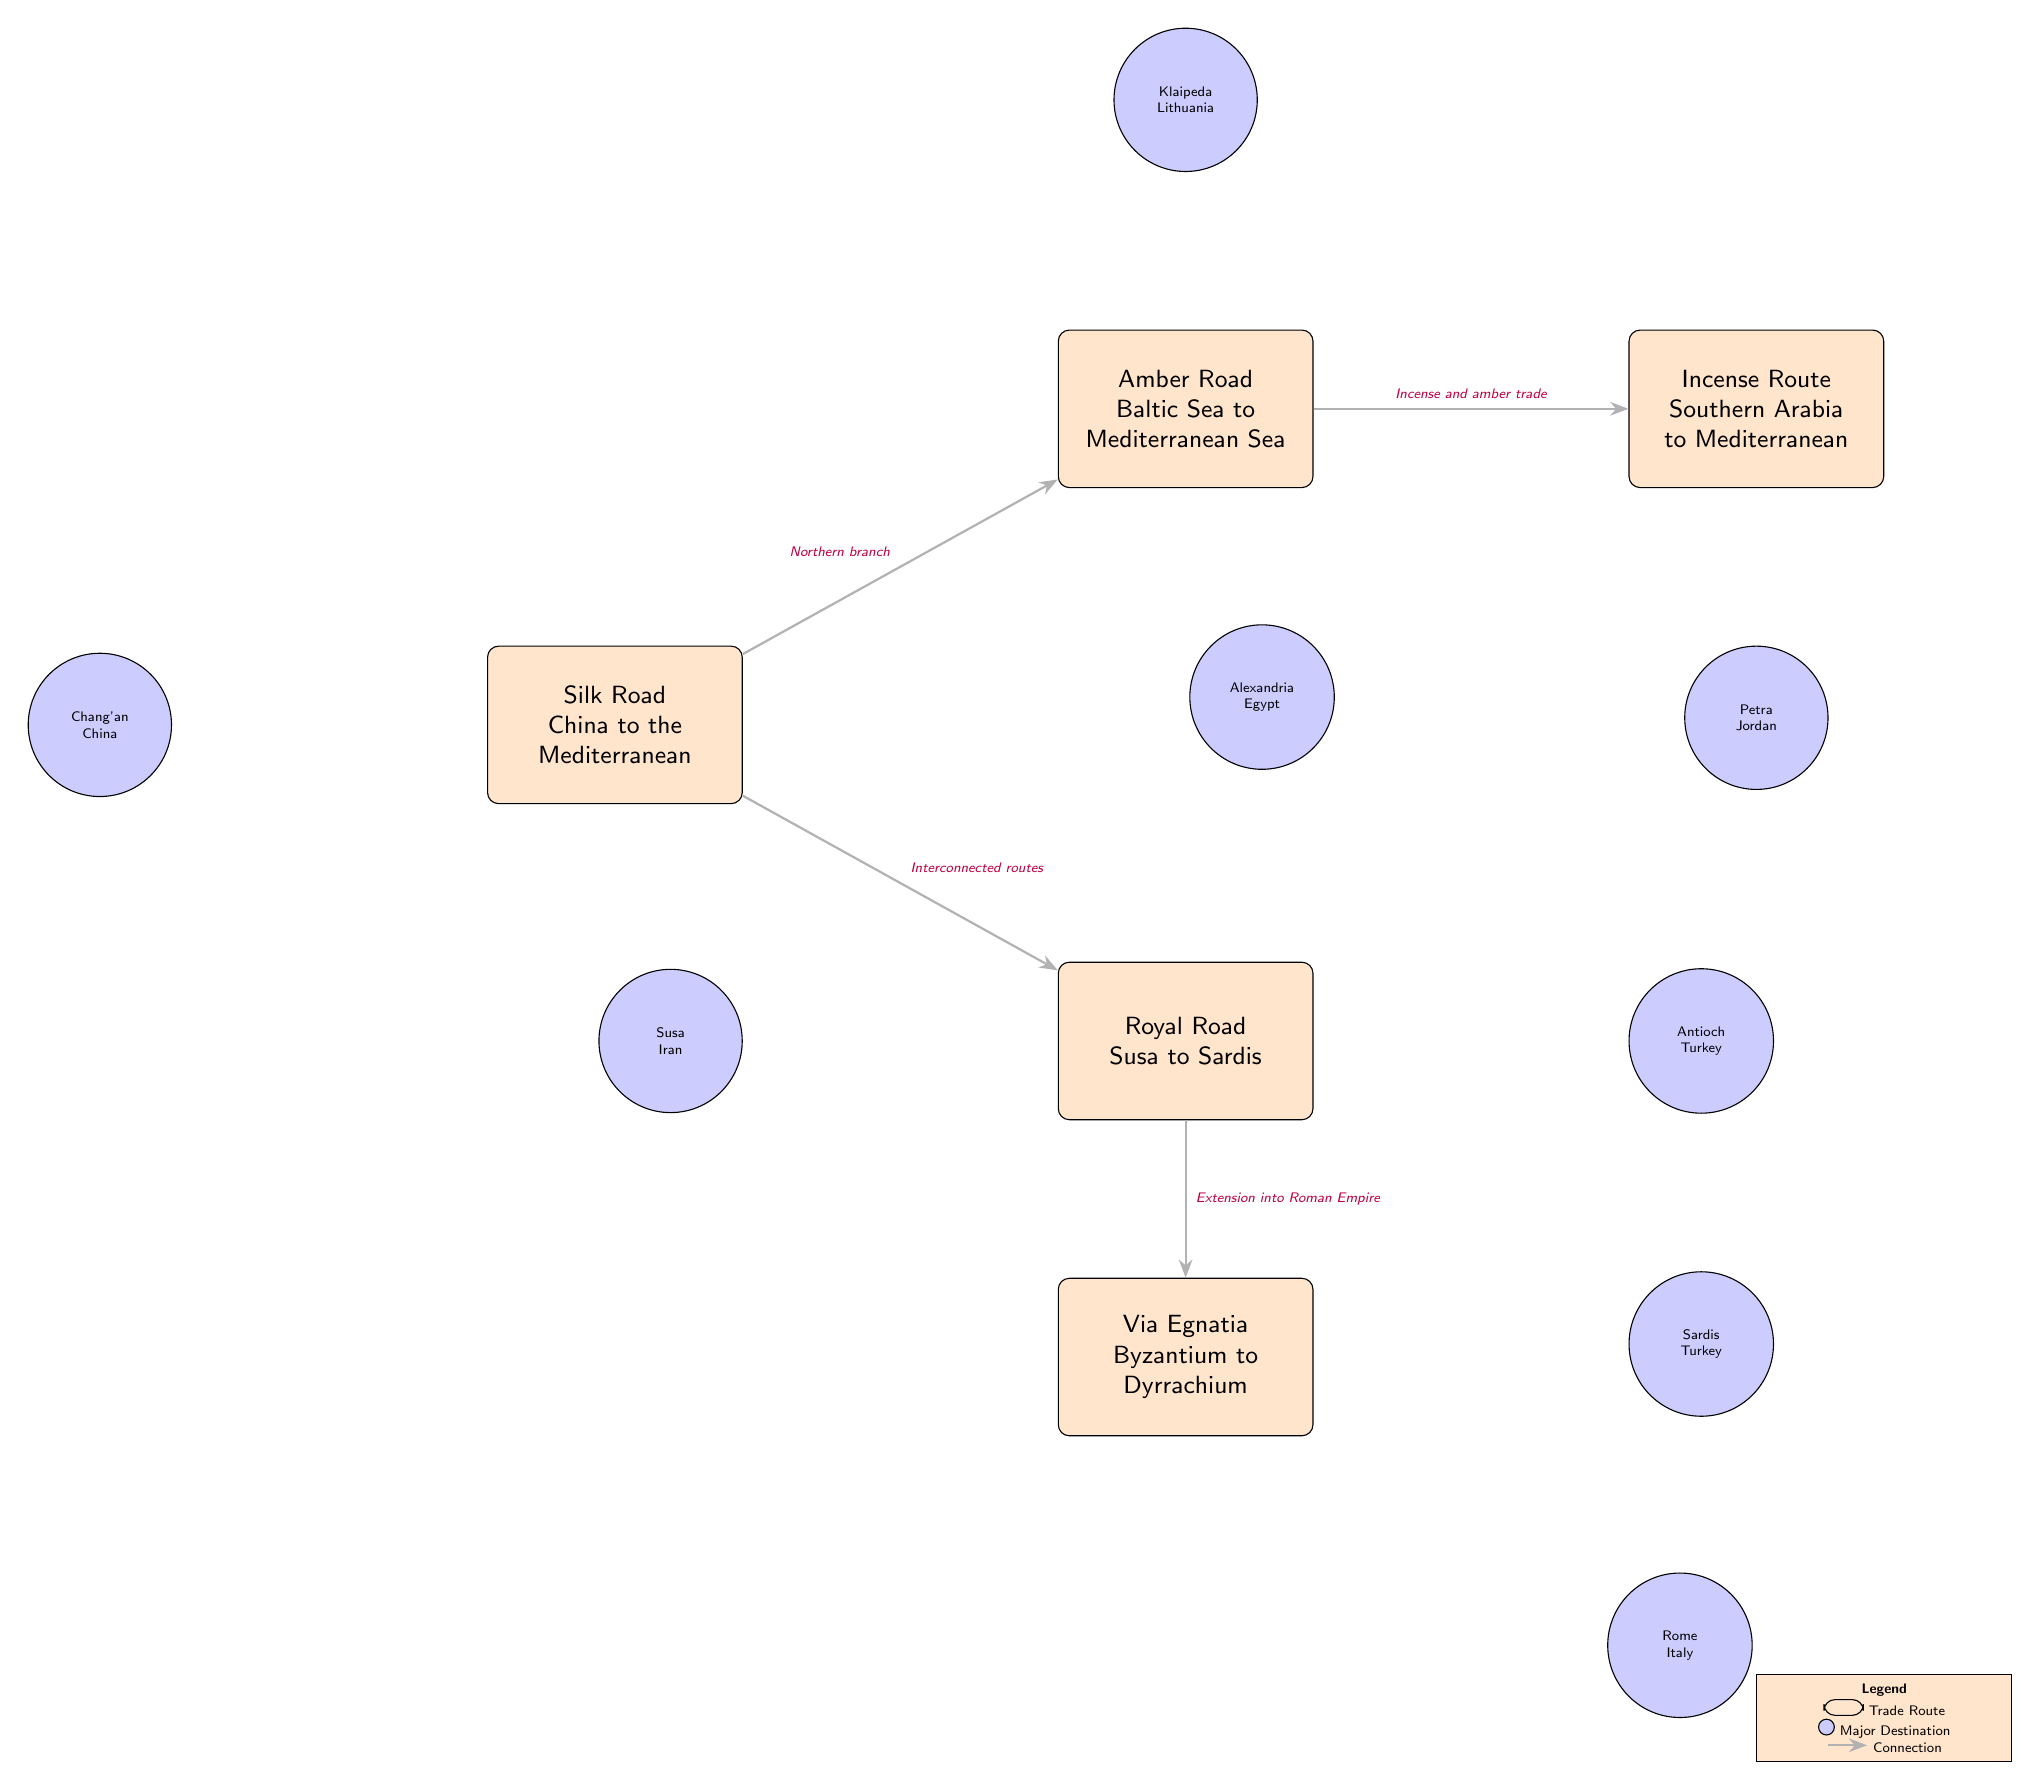What are the starting and ending points of the Silk Road? The Silk Road begins at Chang'an in China and extends to the Mediterranean region.
Answer: Chang'an, Mediterranean How many major trade routes are displayed in the diagram? There are five major trade routes illustrated in the diagram: Silk Road, Royal Road, Amber Road, Via Egnatia, and Incense Route.
Answer: 5 What destination is located to the left of the Royal Road? The destination to the left of the Royal Road is Susa, which is situated in Iran.
Answer: Susa Which two routes are interconnected according to the diagram? The Silk Road and the Royal Road are interconnected, suggesting a direct link or relationship between them.
Answer: Silk Road, Royal Road Which route connects Byzantium to Dyrrachium? The trade route that connects Byzantium to Dyrrachium is known as the Via Egnatia.
Answer: Via Egnatia What major destination is connected to the Amber Road? The Amber Road connects to the major destination of Klaipeda, which is located in Lithuania.
Answer: Klaipeda Which route is described as an extension into the Roman Empire? The route that is described as an extension into the Roman Empire is the Via Egnatia.
Answer: Via Egnatia How many connections are there between the trade routes in the diagram? There are four connections illustrated in the diagram between the trade routes, indicating their interrelationships.
Answer: 4 What color indicates a trade route in the diagram? The color indicating a trade route in the diagram is orange.
Answer: Orange 